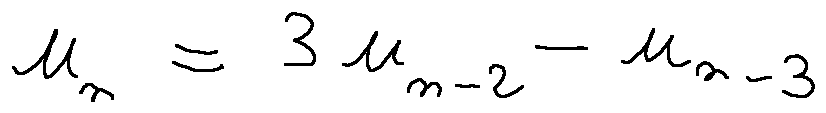Convert formula to latex. <formula><loc_0><loc_0><loc_500><loc_500>u _ { n } = 3 u _ { n - 2 } - u _ { n - 3 }</formula> 